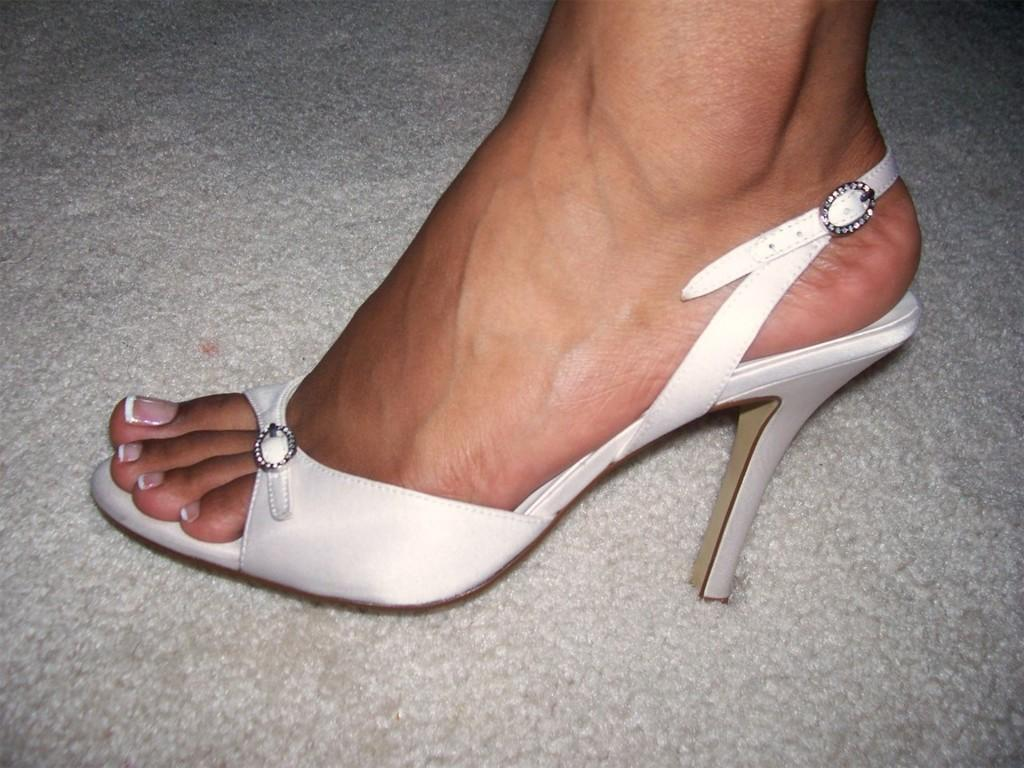What part of a person can be seen in the image? There is a leg of a person in the image. What is the person wearing on their leg? The person is wearing footwear. Where is the basin and faucet located in the image? There is no basin or faucet present in the image; it only shows a leg of a person wearing footwear. 